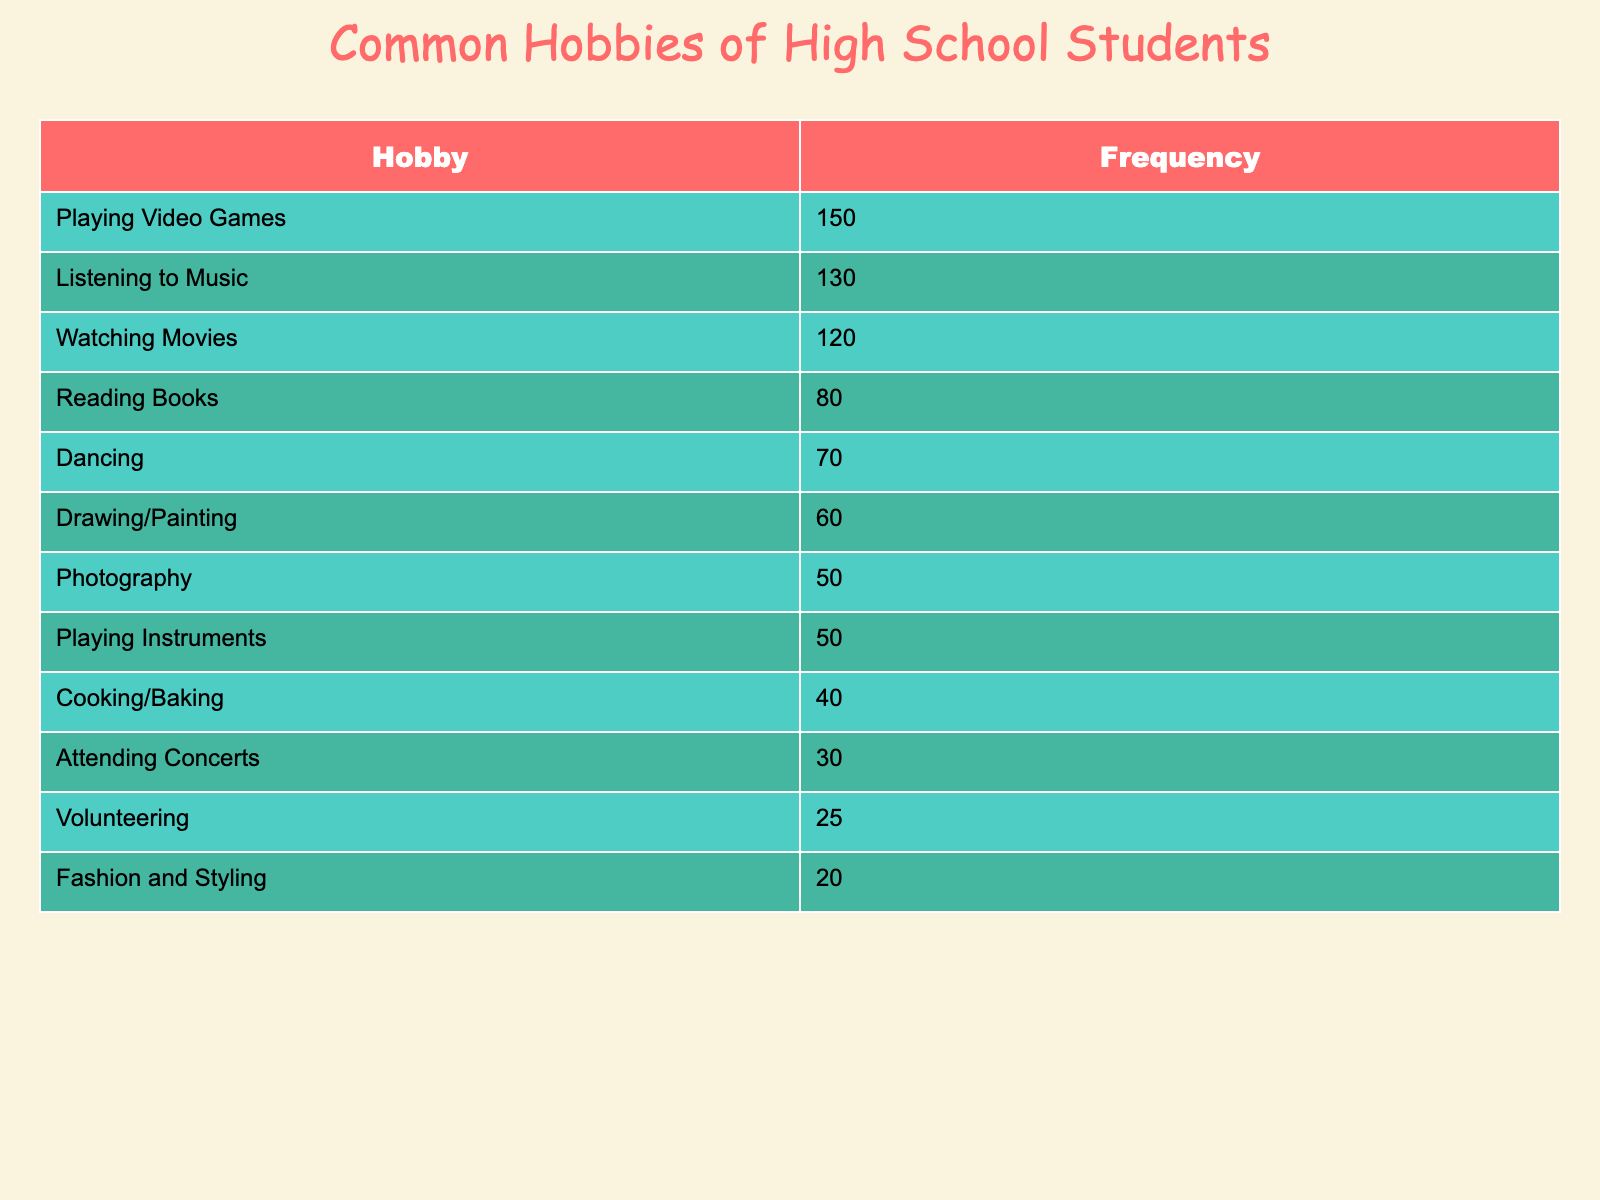What is the most popular hobby among high school students? The table shows the frequency of various hobbies among high school students. The hobby with the highest frequency is "Playing Video Games," with a frequency of 150.
Answer: Playing Video Games How many students are interested in "Cooking/Baking"? According to the table, the frequency of students interested in "Cooking/Baking" is 40.
Answer: 40 What is the least popular hobby listed in the table? The frequency of "Fashion and Styling" is 20, which is lower than any other hobby listed in the table, making it the least popular.
Answer: Fashion and Styling What is the combined frequency of "Drawing/Painting" and "Photography"? To find this, we add the frequencies of both hobbies: 60 for "Drawing/Painting" and 50 for "Photography". So, 60 + 50 = 110.
Answer: 110 Is the frequency of students who like to dance greater than those who enjoy attending concerts? The frequency for "Dancing" is 70, and for "Attending Concerts," it is 30. Since 70 is greater than 30, the statement is true.
Answer: Yes What is the average frequency of the top three hobbies? The top three hobbies are "Playing Video Games" (150), "Listening to Music" (130), and "Watching Movies" (120). Their total frequency is 150 + 130 + 120 = 400. To find the average, divide by 3: 400/3 ≈ 133.33.
Answer: Approximately 133.33 Which hobby has a frequency of exactly 50? The table indicates that both "Photography" and "Playing Instruments" have a frequency of 50.
Answer: Photography and Playing Instruments How many more students enjoy "Listening to Music" than "Reading Books"? The frequency for "Listening to Music" is 130 and for "Reading Books" it is 80. The difference is calculated as 130 - 80 = 50, meaning 50 more students enjoy "Listening to Music."
Answer: 50 What percentage of students prefer "Volunteering" compared to the total frequency of all hobbies? First, we sum the frequencies: 150 + 120 + 130 + 80 + 60 + 50 + 40 + 70 + 50 + 30 + 25 + 20 = 975. The frequency of "Volunteering" is 25. To find the percentage: (25 / 975) * 100 ≈ 2.56%.
Answer: Approximately 2.56% 